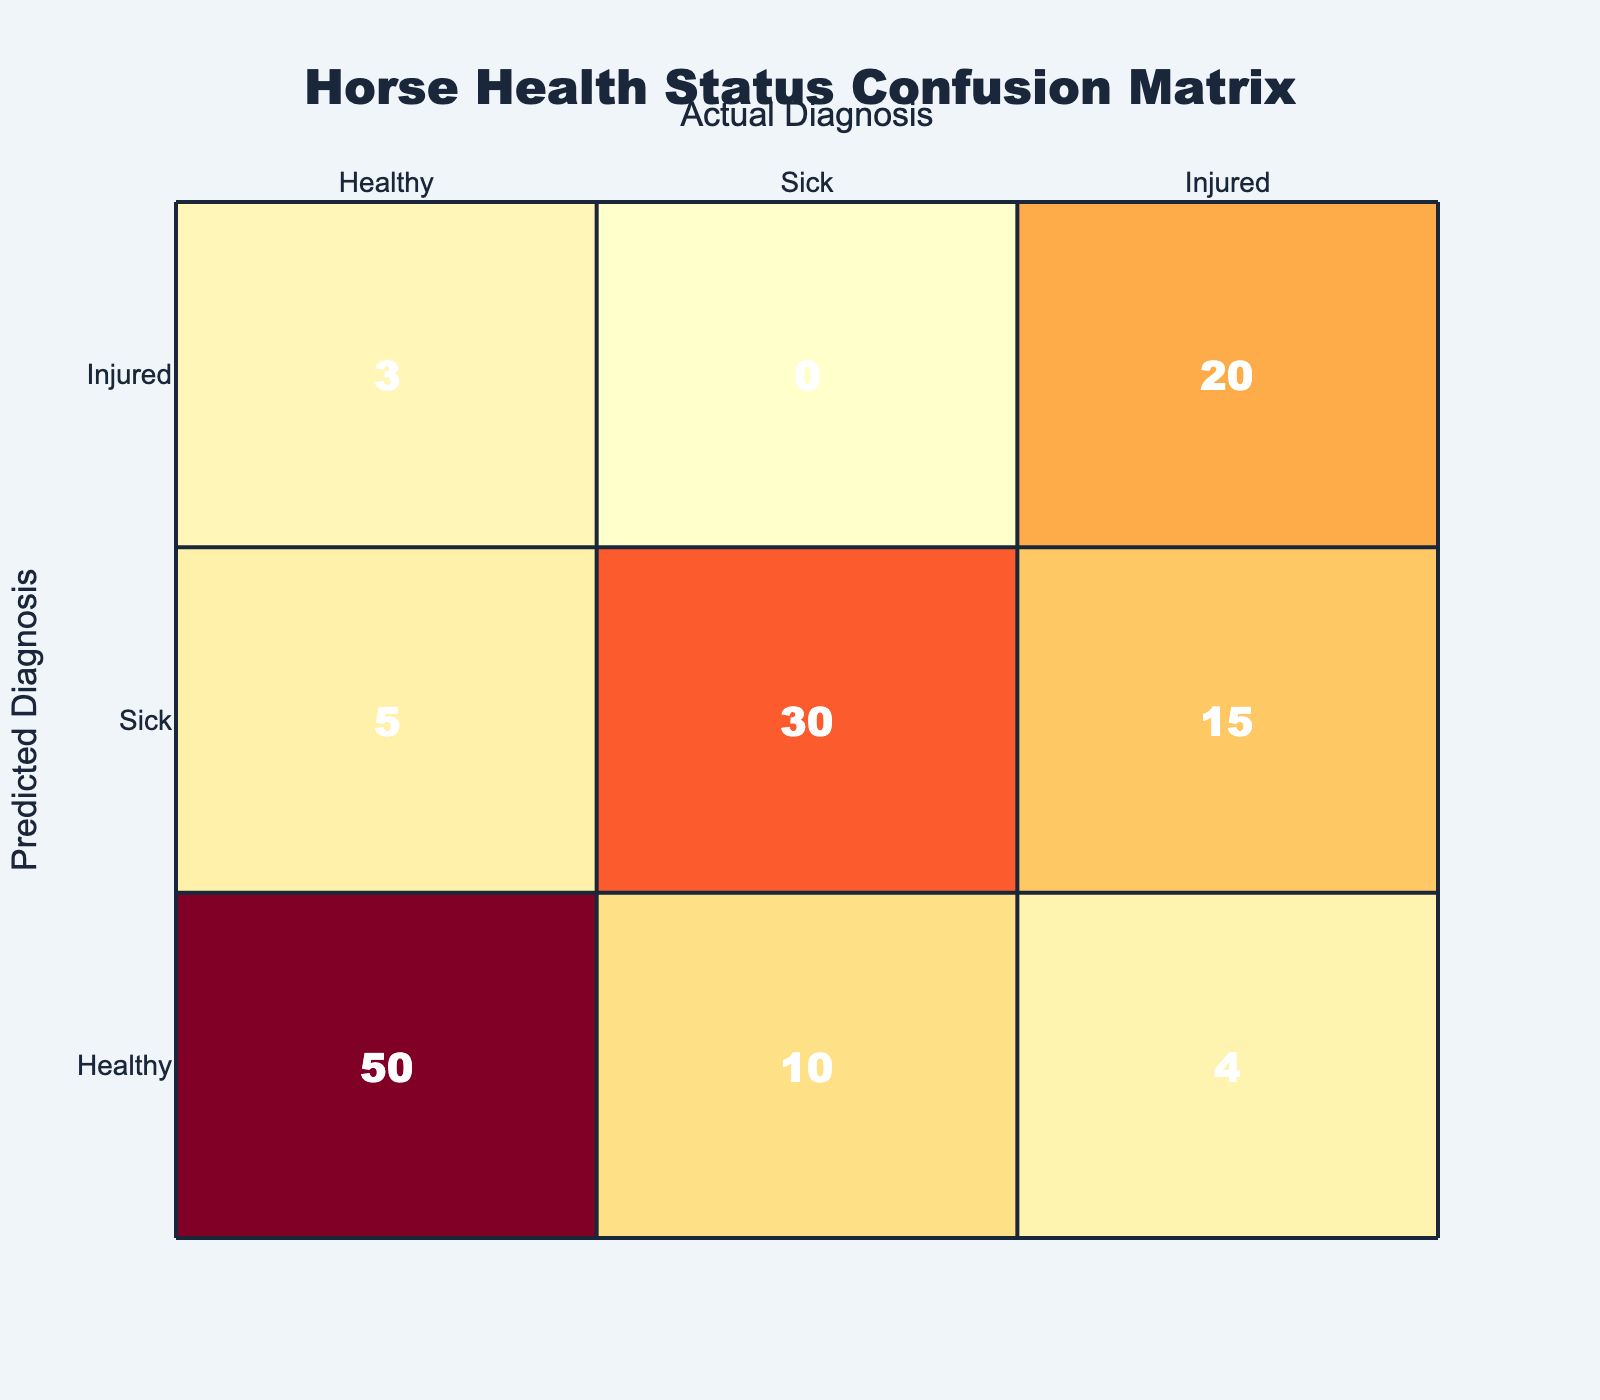What is the number of True Positives for Sick diagnoses? The True Positives for Sick diagnoses can be found in the row where both the predicted and actual diagnosis are Sick. Looking at that row, the value is 30.
Answer: 30 What is the total number of instances where horses were predicted as Healthy? To find this total, we sum the True Positives and False Positives for the Healthy prediction: True Positives (50) + False Positives (5) + False Negatives (10) + True Negatives (43) = 108.
Answer: 108 How many instances of Healthy horses were identified incorrectly? Incorrect identifications of Healthy horses include False Positives (5) and False Negatives (10). So, the total is 5 + 10 = 15.
Answer: 15 Is it true that the number of True Positives for Injured diagnoses is greater than that for Sick diagnoses? The True Positives for Injured is 20 and for Sick is 30. Comparing these numbers, 20 is less than 30, so it is false.
Answer: False What is the combined number of True Negatives for Healthy and Sick diagnoses? The True Negatives for Healthy is 43 and for Sick is 72. Adding these two figures gives 43 + 72 = 115.
Answer: 115 What percentage of the total diagnoses are correctly predicted for Sick horses? To get this percentage, we need to calculate the True Positives for Sick (30) divided by the total instances of Sick diagnoses (True Positives + False Negatives: 30 + 10 + 15 = 55). So, (30/55) * 100 = approximately 54.55%.
Answer: 54.55% How many instances of injured horses were predicted as Healthy? The value for instances of Injured horses being predicted as Healthy can be found in the row for "Healthy" where the Actual Diagnosis is "Injured". The number is 4.
Answer: 4 What is the highest number of True Positives for any diagnosis? By inspecting the True Positive counts, the highest is for Sick with 30.
Answer: 30 